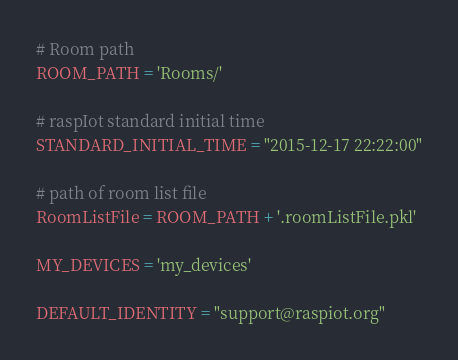<code> <loc_0><loc_0><loc_500><loc_500><_Python_># Room path
ROOM_PATH = 'Rooms/'

# raspIot standard initial time
STANDARD_INITIAL_TIME = "2015-12-17 22:22:00"

# path of room list file
RoomListFile = ROOM_PATH + '.roomListFile.pkl'

MY_DEVICES = 'my_devices'

DEFAULT_IDENTITY = "support@raspiot.org"</code> 